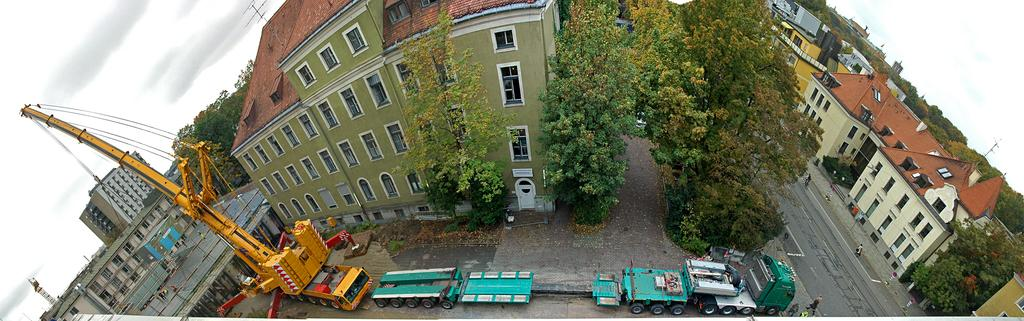What types of objects can be seen in the image? There are vehicles in the image. What can be seen in the background of the image? There are buildings in the background of the image. What colors are the buildings? The buildings have cream, yellow, and green colors. What else can be seen in the image besides vehicles and buildings? There are trees in the image. What color are the trees? The trees have a green color. What else is visible in the image? The sky is visible in the image. What color is the sky? The sky has a white color. Where is the throne located in the image? There is no throne present in the image. What type of feather can be seen in the image? There are no feathers present in the image. 